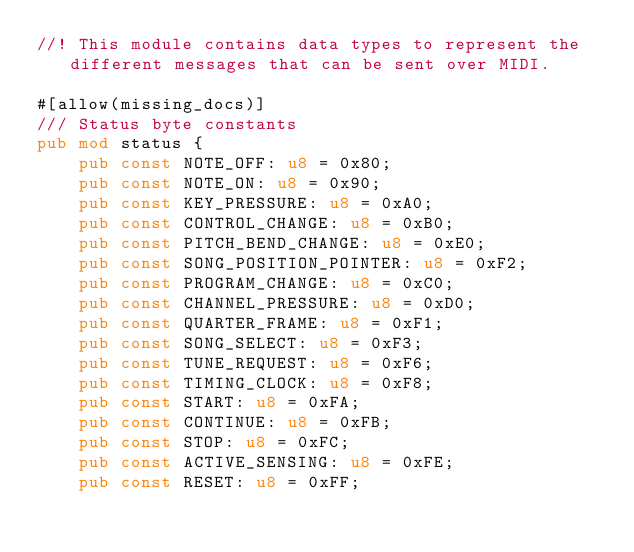<code> <loc_0><loc_0><loc_500><loc_500><_Rust_>//! This module contains data types to represent the different messages that can be sent over MIDI.

#[allow(missing_docs)]
/// Status byte constants
pub mod status {
    pub const NOTE_OFF: u8 = 0x80;
    pub const NOTE_ON: u8 = 0x90;
    pub const KEY_PRESSURE: u8 = 0xA0;
    pub const CONTROL_CHANGE: u8 = 0xB0;
    pub const PITCH_BEND_CHANGE: u8 = 0xE0;
    pub const SONG_POSITION_POINTER: u8 = 0xF2;
    pub const PROGRAM_CHANGE: u8 = 0xC0;
    pub const CHANNEL_PRESSURE: u8 = 0xD0;
    pub const QUARTER_FRAME: u8 = 0xF1;
    pub const SONG_SELECT: u8 = 0xF3;
    pub const TUNE_REQUEST: u8 = 0xF6;
    pub const TIMING_CLOCK: u8 = 0xF8;
    pub const START: u8 = 0xFA;
    pub const CONTINUE: u8 = 0xFB;
    pub const STOP: u8 = 0xFC;
    pub const ACTIVE_SENSING: u8 = 0xFE;
    pub const RESET: u8 = 0xFF;
</code> 